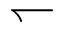Convert formula to latex. <formula><loc_0><loc_0><loc_500><loc_500>\leftharpoondown</formula> 